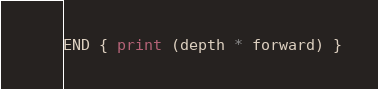<code> <loc_0><loc_0><loc_500><loc_500><_Awk_>END { print (depth * forward) }
</code> 